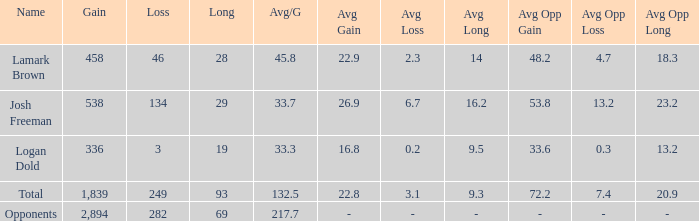How much Gain has a Long of 29, and an Avg/G smaller than 33.7? 0.0. 